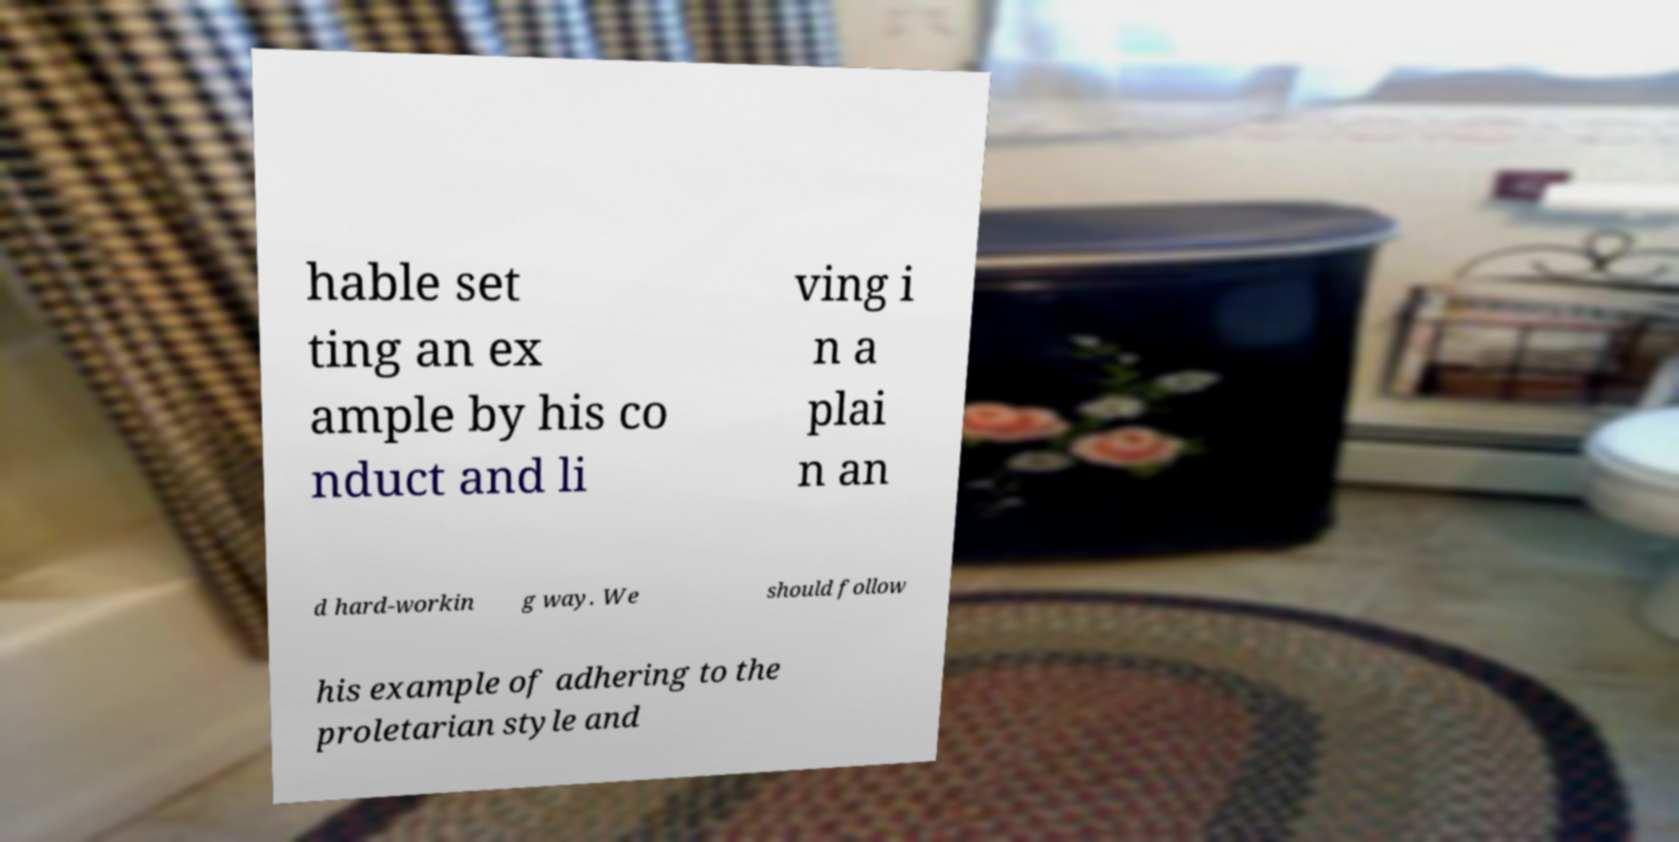Can you read and provide the text displayed in the image?This photo seems to have some interesting text. Can you extract and type it out for me? hable set ting an ex ample by his co nduct and li ving i n a plai n an d hard-workin g way. We should follow his example of adhering to the proletarian style and 